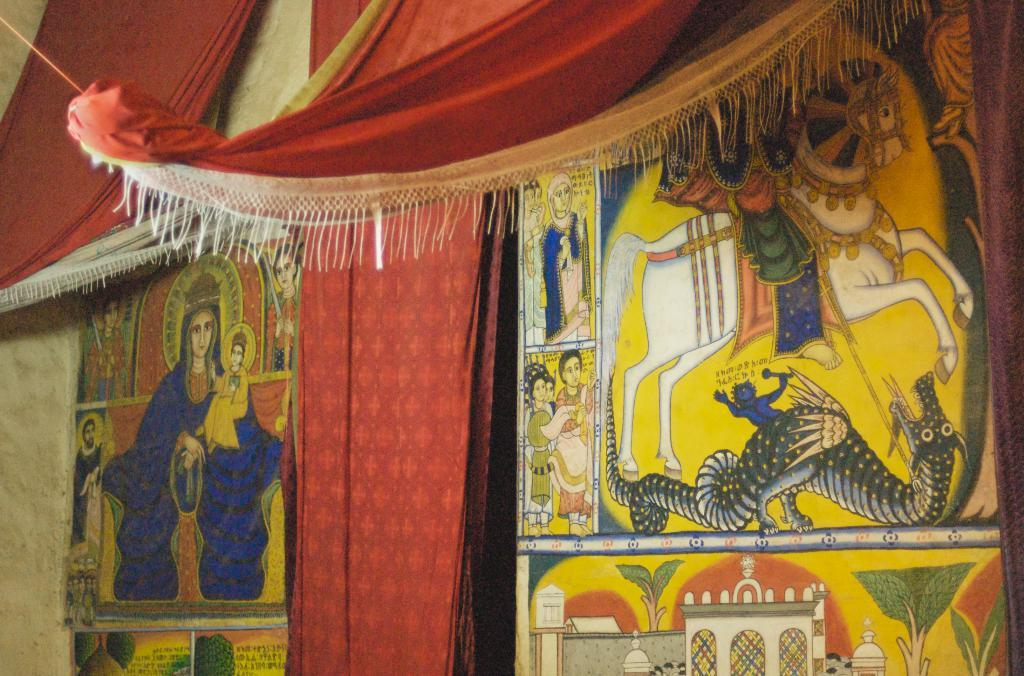What can be seen hanging in the image? There are clothes hanging in the image. What color are the clothes? The clothes are red in color. What else is present on the wall in the image? There are wall paintings in the image. How were the wall paintings created? The wall paintings were drawn on the wall. Is there a beggar asking for polish for their book in the image? No, there is no beggar or book present in the image. 